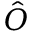<formula> <loc_0><loc_0><loc_500><loc_500>\hat { O }</formula> 